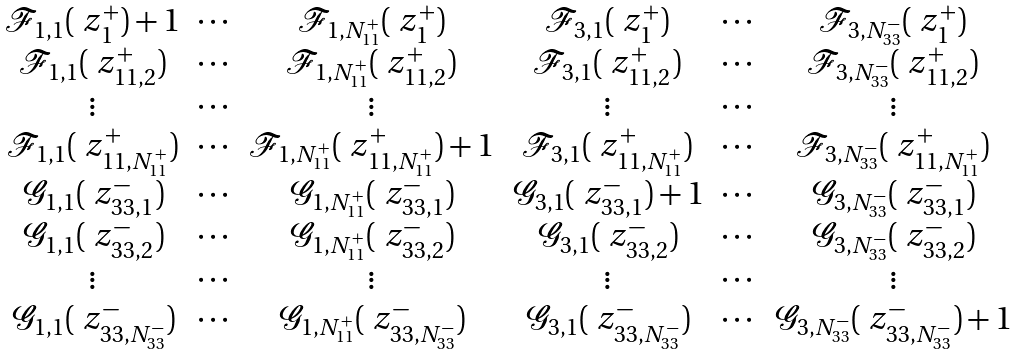Convert formula to latex. <formula><loc_0><loc_0><loc_500><loc_500>\begin{matrix} \mathcal { F } _ { 1 , 1 } ( \ z _ { 1 } ^ { + } ) + 1 & \cdots & \mathcal { F } _ { 1 , N _ { 1 1 } ^ { + } } ( \ z _ { 1 } ^ { + } ) & \mathcal { F } _ { 3 , 1 } ( \ z _ { 1 } ^ { + } ) & \cdots & \mathcal { F } _ { 3 , N _ { 3 3 } ^ { - } } ( \ z _ { 1 } ^ { + } ) \\ \mathcal { F } _ { 1 , 1 } ( \ z _ { 1 1 , 2 } ^ { + } ) & \cdots & \mathcal { F } _ { 1 , N _ { 1 1 } ^ { + } } ( \ z _ { 1 1 , 2 } ^ { + } ) & \mathcal { F } _ { 3 , 1 } ( \ z _ { 1 1 , 2 } ^ { + } ) & \cdots & \mathcal { F } _ { 3 , N _ { 3 3 } ^ { - } } ( \ z _ { 1 1 , 2 } ^ { + } ) \\ \vdots & \cdots & \vdots & \vdots & \cdots & \vdots \\ \mathcal { F } _ { 1 , 1 } ( \ z _ { 1 1 , N _ { 1 1 } ^ { + } } ^ { + } ) & \cdots & \mathcal { F } _ { 1 , N _ { 1 1 } ^ { + } } ( \ z _ { 1 1 , N _ { 1 1 } ^ { + } } ^ { + } ) + 1 & \mathcal { F } _ { 3 , 1 } ( \ z _ { 1 1 , N _ { 1 1 } ^ { + } } ^ { + } ) & \cdots & \mathcal { F } _ { 3 , N _ { 3 3 } ^ { - } } ( \ z _ { 1 1 , N _ { 1 1 } ^ { + } } ^ { + } ) \\ \mathcal { G } _ { 1 , 1 } ( \ z _ { 3 3 , 1 } ^ { - } ) & \cdots & \mathcal { G } _ { 1 , N _ { 1 1 } ^ { + } } ( \ z _ { 3 3 , 1 } ^ { - } ) & \mathcal { G } _ { 3 , 1 } ( \ z _ { 3 3 , 1 } ^ { - } ) + 1 & \cdots & \mathcal { G } _ { 3 , N _ { 3 3 } ^ { - } } ( \ z _ { 3 3 , 1 } ^ { - } ) \\ \mathcal { G } _ { 1 , 1 } ( \ z _ { 3 3 , 2 } ^ { - } ) & \cdots & \mathcal { G } _ { 1 , N _ { 1 1 } ^ { + } } ( \ z _ { 3 3 , 2 } ^ { - } ) & \mathcal { G } _ { 3 , 1 } ( \ z _ { 3 3 , 2 } ^ { - } ) & \cdots & \mathcal { G } _ { 3 , N _ { 3 3 } ^ { - } } ( \ z _ { 3 3 , 2 } ^ { - } ) \\ \vdots & \cdots & \vdots & \vdots & \cdots & \vdots \\ \mathcal { G } _ { 1 , 1 } ( \ z _ { 3 3 , N _ { 3 3 } ^ { - } } ^ { - } ) & \cdots & \mathcal { G } _ { 1 , N _ { 1 1 } ^ { + } } ( \ z _ { 3 3 , N _ { 3 3 } ^ { - } } ^ { - } ) & \mathcal { G } _ { 3 , 1 } ( \ z _ { 3 3 , N _ { 3 3 } ^ { - } } ^ { - } ) & \cdots & \mathcal { G } _ { 3 , N _ { 3 3 } ^ { - } } ( \ z _ { 3 3 , N _ { 3 3 } ^ { - } } ^ { - } ) + 1 \end{matrix}</formula> 